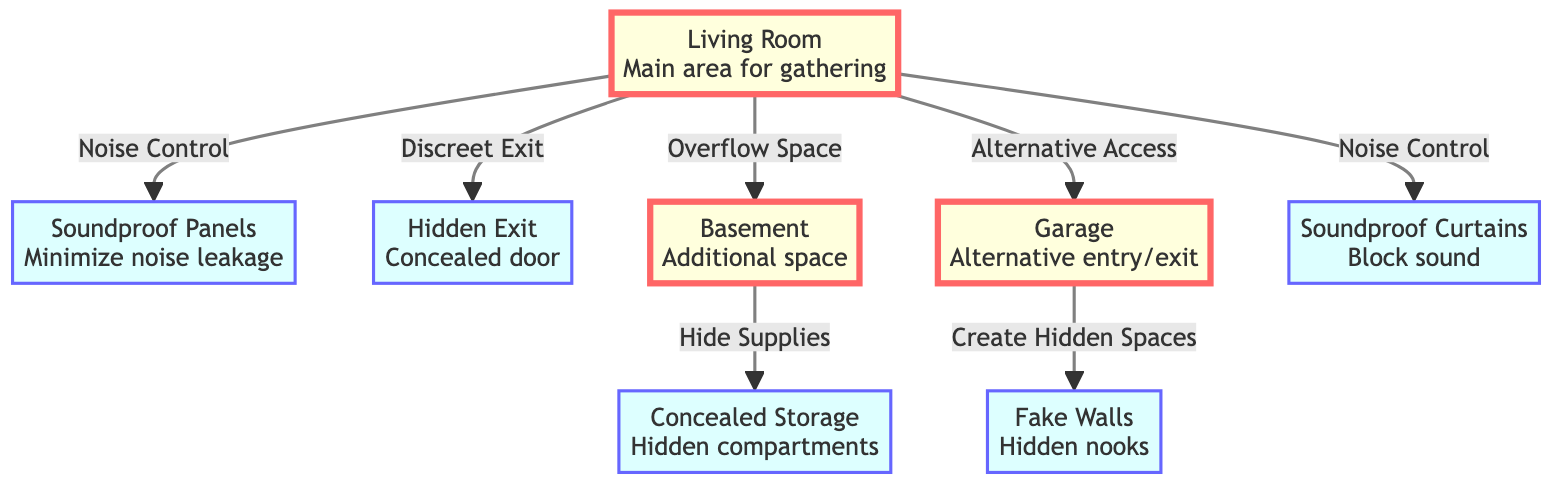What is the main area for gathering? The diagram indicates that the "Living Room" is labeled as the main area for gathering, with arrows pointing to it from soundproofing materials and other features.
Answer: Living Room How many soundproofing features are there? The diagram includes three distinct soundproofing features: soundproof panels, soundproof curtains, and fake walls.
Answer: 3 What is a concealed storage space used for? The diagram shows that concealed storage is used to "Hide Supplies," indicating its primary purpose in the context of the party setup.
Answer: Hide Supplies Which room provides alternative access? The "Garage" is marked in the diagram and is connected to the living room as an alternative access point, suggesting it offers a secondary way in or out.
Answer: Garage What connects the living room to the basement? The connection shown in the diagram between the living room and basement indicates that the basement serves as "Overflow Space."
Answer: Overflow Space How many hidden exits are shown in the diagram? The diagram clearly identifies one hidden exit from the living room, connecting discreetly to the overall layout.
Answer: 1 Which soundproofing feature minimizes noise leakage? The feature labeled as "Soundproof Panels" in the diagram is explicitly noted to minimize noise leakage, fulfilling this function.
Answer: Soundproof Panels What is the purpose of fake walls? According to the diagram, fake walls are intended to "Create Hidden Spaces," suggesting their function within the celebration context.
Answer: Create Hidden Spaces What main features are linked to noise control? Two features are specifically indicated as linked to noise control: soundproof panels and soundproof curtains, denoting their shared purpose.
Answer: Soundproof Panels, Soundproof Curtains 